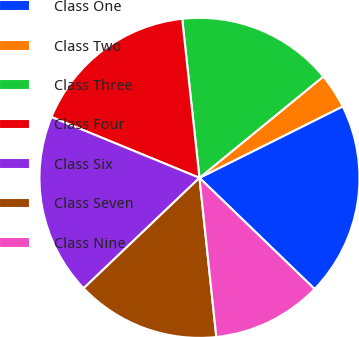Convert chart to OTSL. <chart><loc_0><loc_0><loc_500><loc_500><pie_chart><fcel>Class One<fcel>Class Two<fcel>Class Three<fcel>Class Four<fcel>Class Six<fcel>Class Seven<fcel>Class Nine<nl><fcel>19.59%<fcel>3.55%<fcel>15.81%<fcel>17.07%<fcel>18.33%<fcel>14.56%<fcel>11.1%<nl></chart> 